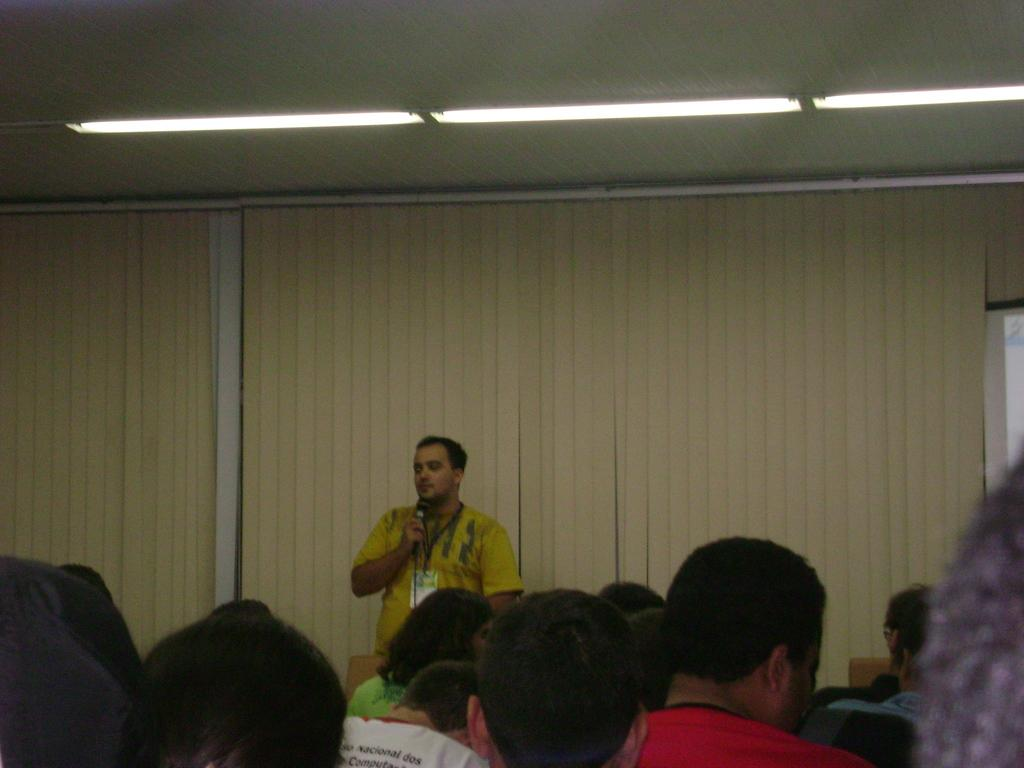What is happening in the image involving the group of people? There is a man holding a mic in the image, which suggests that he might be addressing the group or performing for them. How is the man holding the mic? The man is holding the mic with his hand. What can be seen in the background of the image? There are lights and curtains in the background of the image. What type of pan is hanging from the curtains in the image? There is no pan present in the image; it features a man holding a mic in front of a group of people with lights and curtains in the background. How many trees are visible in the image? There are no trees visible in the image. 